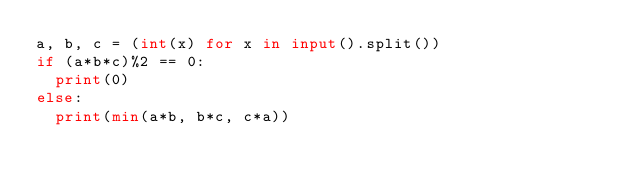<code> <loc_0><loc_0><loc_500><loc_500><_Python_>a, b, c = (int(x) for x in input().split())
if (a*b*c)%2 == 0:
  print(0)
else:
  print(min(a*b, b*c, c*a))</code> 